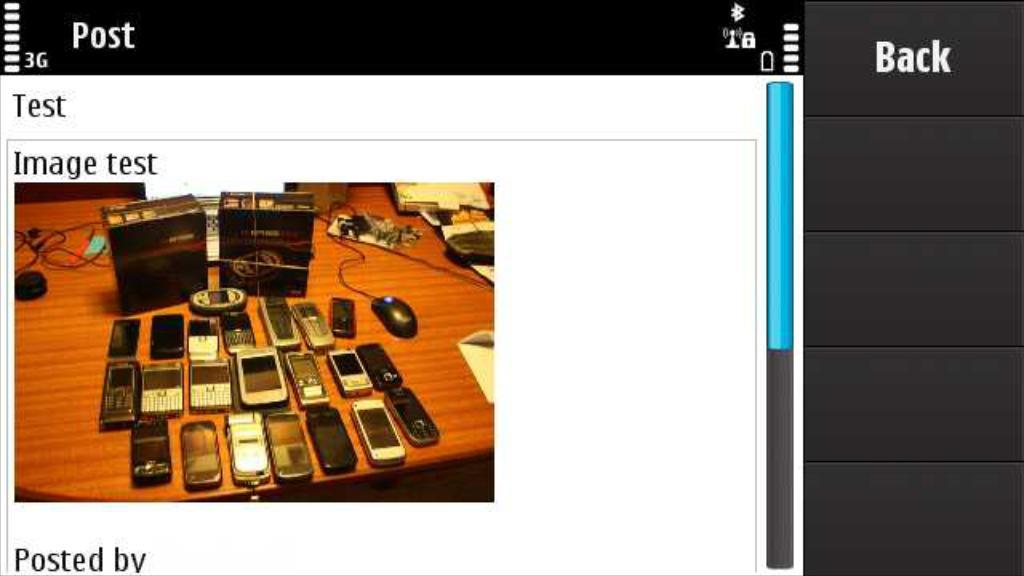<image>
Share a concise interpretation of the image provided. A picture of many old mobile phones is part of a phone image that says image test. 